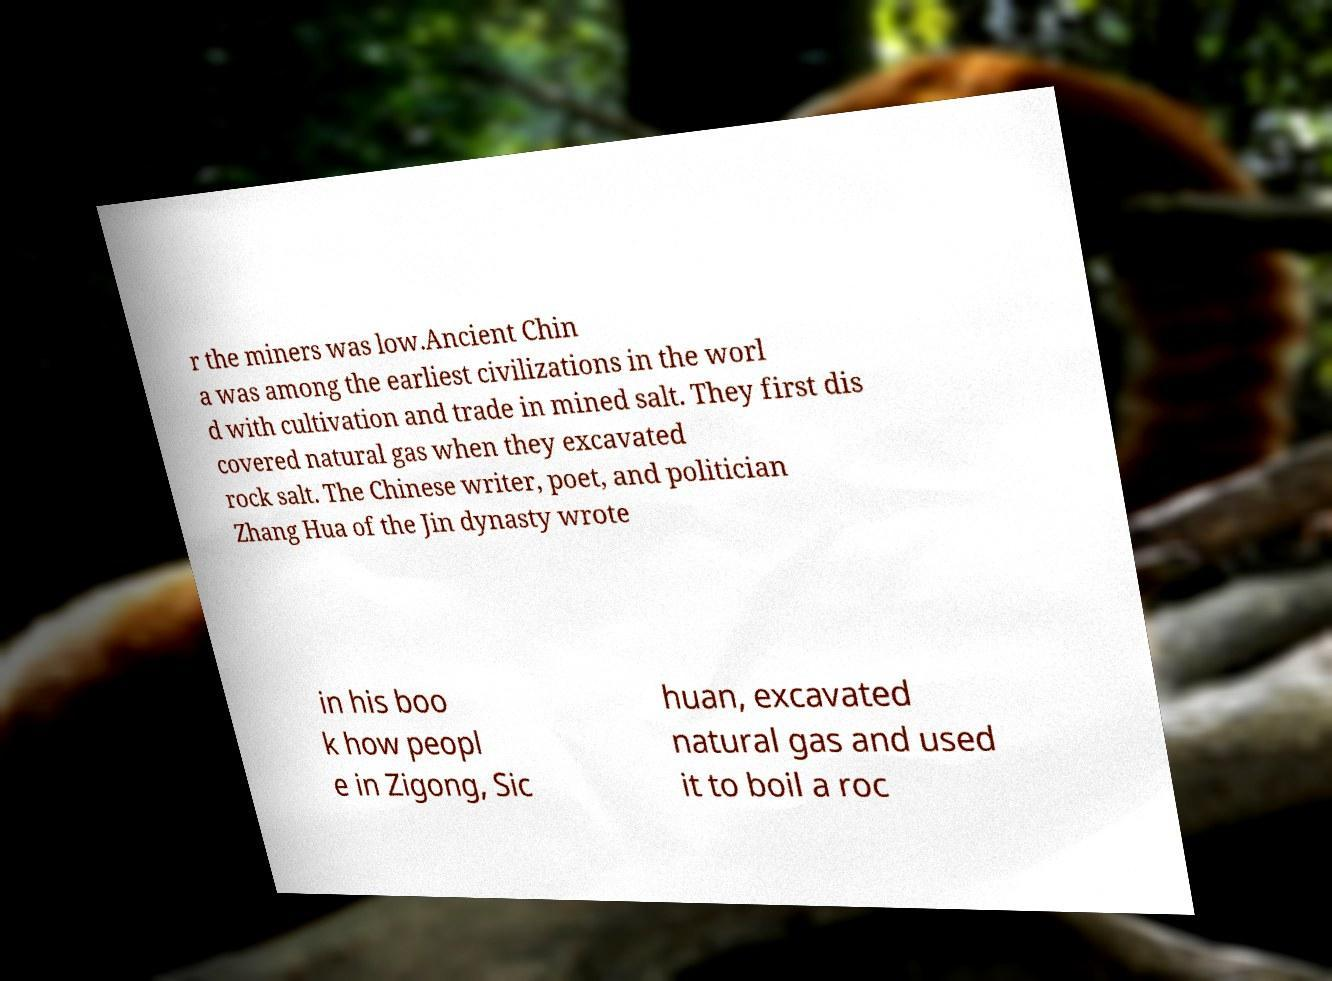Could you assist in decoding the text presented in this image and type it out clearly? r the miners was low.Ancient Chin a was among the earliest civilizations in the worl d with cultivation and trade in mined salt. They first dis covered natural gas when they excavated rock salt. The Chinese writer, poet, and politician Zhang Hua of the Jin dynasty wrote in his boo k how peopl e in Zigong, Sic huan, excavated natural gas and used it to boil a roc 